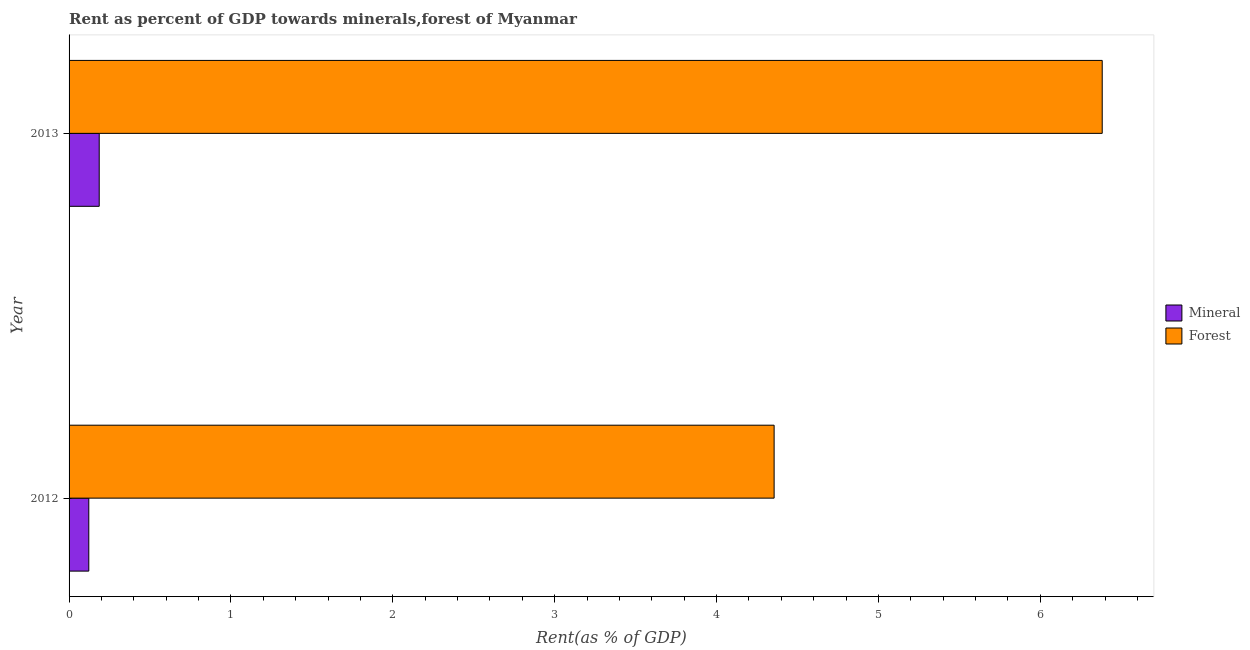How many groups of bars are there?
Your response must be concise. 2. Are the number of bars per tick equal to the number of legend labels?
Offer a very short reply. Yes. Are the number of bars on each tick of the Y-axis equal?
Offer a terse response. Yes. What is the mineral rent in 2013?
Your answer should be compact. 0.19. Across all years, what is the maximum forest rent?
Provide a short and direct response. 6.38. Across all years, what is the minimum forest rent?
Ensure brevity in your answer.  4.36. In which year was the forest rent maximum?
Provide a short and direct response. 2013. In which year was the forest rent minimum?
Ensure brevity in your answer.  2012. What is the total mineral rent in the graph?
Your answer should be very brief. 0.31. What is the difference between the mineral rent in 2012 and that in 2013?
Make the answer very short. -0.06. What is the difference between the mineral rent in 2012 and the forest rent in 2013?
Your answer should be very brief. -6.26. What is the average mineral rent per year?
Provide a succinct answer. 0.15. In the year 2012, what is the difference between the forest rent and mineral rent?
Keep it short and to the point. 4.23. In how many years, is the forest rent greater than 6.2 %?
Make the answer very short. 1. What is the ratio of the mineral rent in 2012 to that in 2013?
Your response must be concise. 0.65. Is the mineral rent in 2012 less than that in 2013?
Your answer should be very brief. Yes. In how many years, is the mineral rent greater than the average mineral rent taken over all years?
Offer a terse response. 1. What does the 2nd bar from the top in 2012 represents?
Give a very brief answer. Mineral. What does the 1st bar from the bottom in 2013 represents?
Offer a very short reply. Mineral. How many bars are there?
Give a very brief answer. 4. What is the difference between two consecutive major ticks on the X-axis?
Make the answer very short. 1. Does the graph contain any zero values?
Provide a succinct answer. No. Where does the legend appear in the graph?
Provide a short and direct response. Center right. How many legend labels are there?
Your answer should be compact. 2. How are the legend labels stacked?
Your answer should be compact. Vertical. What is the title of the graph?
Provide a succinct answer. Rent as percent of GDP towards minerals,forest of Myanmar. What is the label or title of the X-axis?
Make the answer very short. Rent(as % of GDP). What is the label or title of the Y-axis?
Make the answer very short. Year. What is the Rent(as % of GDP) of Mineral in 2012?
Make the answer very short. 0.12. What is the Rent(as % of GDP) in Forest in 2012?
Provide a succinct answer. 4.36. What is the Rent(as % of GDP) of Mineral in 2013?
Ensure brevity in your answer.  0.19. What is the Rent(as % of GDP) in Forest in 2013?
Make the answer very short. 6.38. Across all years, what is the maximum Rent(as % of GDP) in Mineral?
Give a very brief answer. 0.19. Across all years, what is the maximum Rent(as % of GDP) of Forest?
Offer a terse response. 6.38. Across all years, what is the minimum Rent(as % of GDP) in Mineral?
Provide a short and direct response. 0.12. Across all years, what is the minimum Rent(as % of GDP) in Forest?
Provide a succinct answer. 4.36. What is the total Rent(as % of GDP) of Mineral in the graph?
Your answer should be compact. 0.31. What is the total Rent(as % of GDP) of Forest in the graph?
Offer a very short reply. 10.74. What is the difference between the Rent(as % of GDP) in Mineral in 2012 and that in 2013?
Provide a succinct answer. -0.06. What is the difference between the Rent(as % of GDP) in Forest in 2012 and that in 2013?
Provide a short and direct response. -2.03. What is the difference between the Rent(as % of GDP) in Mineral in 2012 and the Rent(as % of GDP) in Forest in 2013?
Ensure brevity in your answer.  -6.26. What is the average Rent(as % of GDP) in Mineral per year?
Make the answer very short. 0.15. What is the average Rent(as % of GDP) in Forest per year?
Your answer should be compact. 5.37. In the year 2012, what is the difference between the Rent(as % of GDP) of Mineral and Rent(as % of GDP) of Forest?
Provide a succinct answer. -4.23. In the year 2013, what is the difference between the Rent(as % of GDP) in Mineral and Rent(as % of GDP) in Forest?
Your answer should be compact. -6.2. What is the ratio of the Rent(as % of GDP) in Mineral in 2012 to that in 2013?
Provide a succinct answer. 0.65. What is the ratio of the Rent(as % of GDP) in Forest in 2012 to that in 2013?
Provide a short and direct response. 0.68. What is the difference between the highest and the second highest Rent(as % of GDP) of Mineral?
Provide a succinct answer. 0.06. What is the difference between the highest and the second highest Rent(as % of GDP) in Forest?
Ensure brevity in your answer.  2.03. What is the difference between the highest and the lowest Rent(as % of GDP) of Mineral?
Ensure brevity in your answer.  0.06. What is the difference between the highest and the lowest Rent(as % of GDP) in Forest?
Provide a short and direct response. 2.03. 